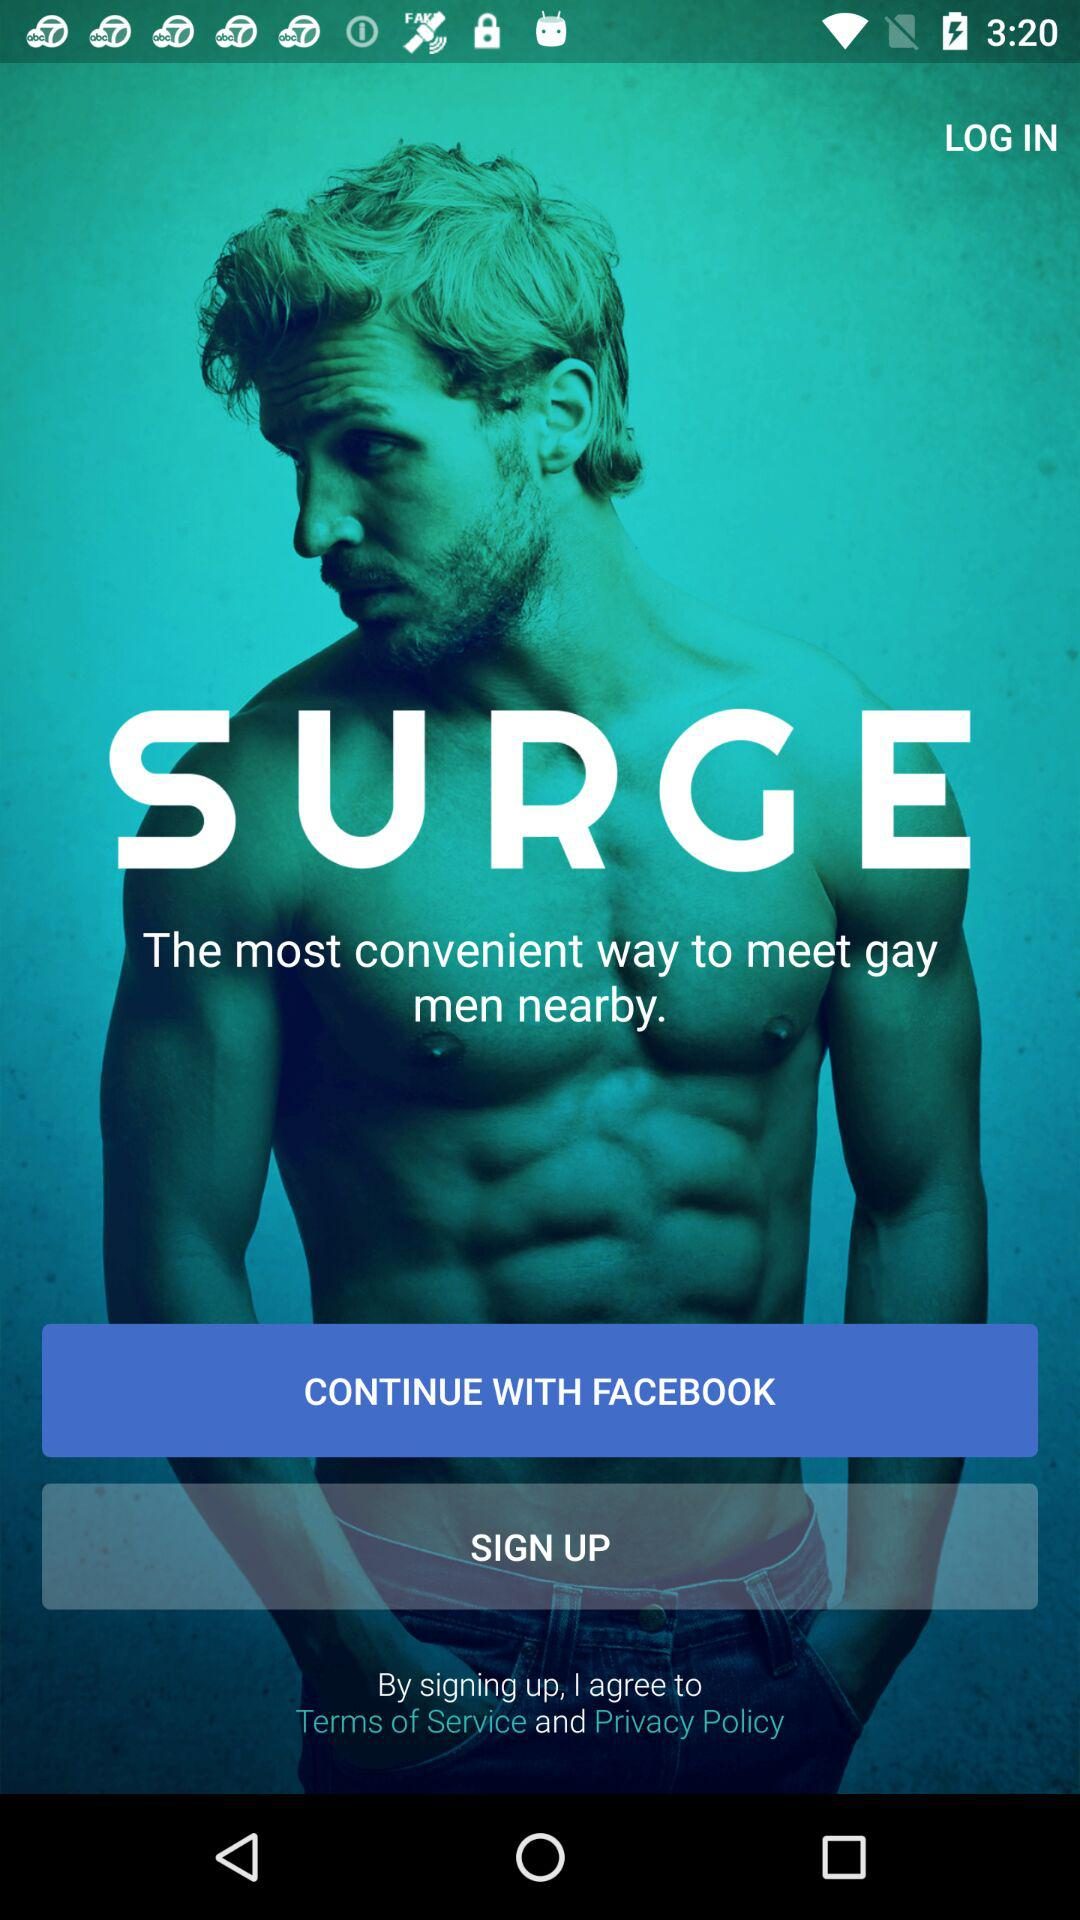What application can we use to sign up? You can use the "Facebook" application to sign up. 